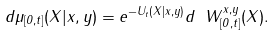<formula> <loc_0><loc_0><loc_500><loc_500>d \mu _ { [ 0 , t ] } ( X | x , y ) = e ^ { - U _ { t } ( X | x , y ) } d \ W ^ { x , y } _ { [ 0 , t ] } ( X ) .</formula> 